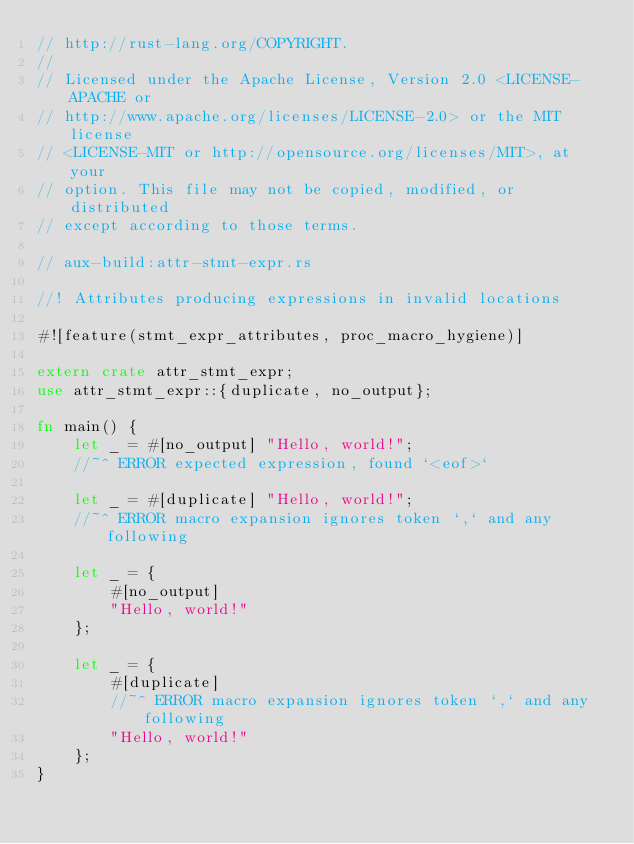<code> <loc_0><loc_0><loc_500><loc_500><_Rust_>// http://rust-lang.org/COPYRIGHT.
//
// Licensed under the Apache License, Version 2.0 <LICENSE-APACHE or
// http://www.apache.org/licenses/LICENSE-2.0> or the MIT license
// <LICENSE-MIT or http://opensource.org/licenses/MIT>, at your
// option. This file may not be copied, modified, or distributed
// except according to those terms.

// aux-build:attr-stmt-expr.rs

//! Attributes producing expressions in invalid locations

#![feature(stmt_expr_attributes, proc_macro_hygiene)]

extern crate attr_stmt_expr;
use attr_stmt_expr::{duplicate, no_output};

fn main() {
    let _ = #[no_output] "Hello, world!";
    //~^ ERROR expected expression, found `<eof>`

    let _ = #[duplicate] "Hello, world!";
    //~^ ERROR macro expansion ignores token `,` and any following

    let _ = {
        #[no_output]
        "Hello, world!"
    };

    let _ = {
        #[duplicate]
        //~^ ERROR macro expansion ignores token `,` and any following
        "Hello, world!"
    };
}
</code> 